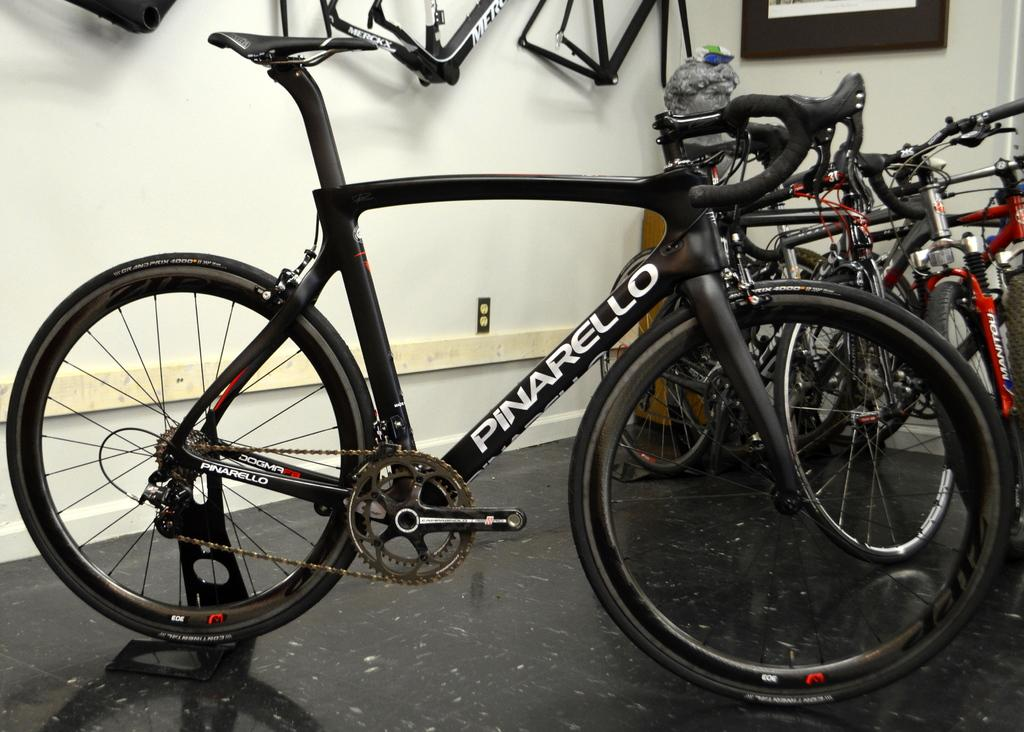What is the main subject in the foreground of the image? There is a bicycle in the foreground of the image. What is the position of the bicycle in the foreground? The bicycle is on the floor. What can be seen in the background of the image? There are bicycles in the background of the image. What is attached to the wall in the background? Bicycle parts are attached to the wall in the background. How many bombs are visible in the image? There are no bombs present in the image. What type of lizards can be seen crawling on the bicycles in the image? There are no lizards present in the image. 